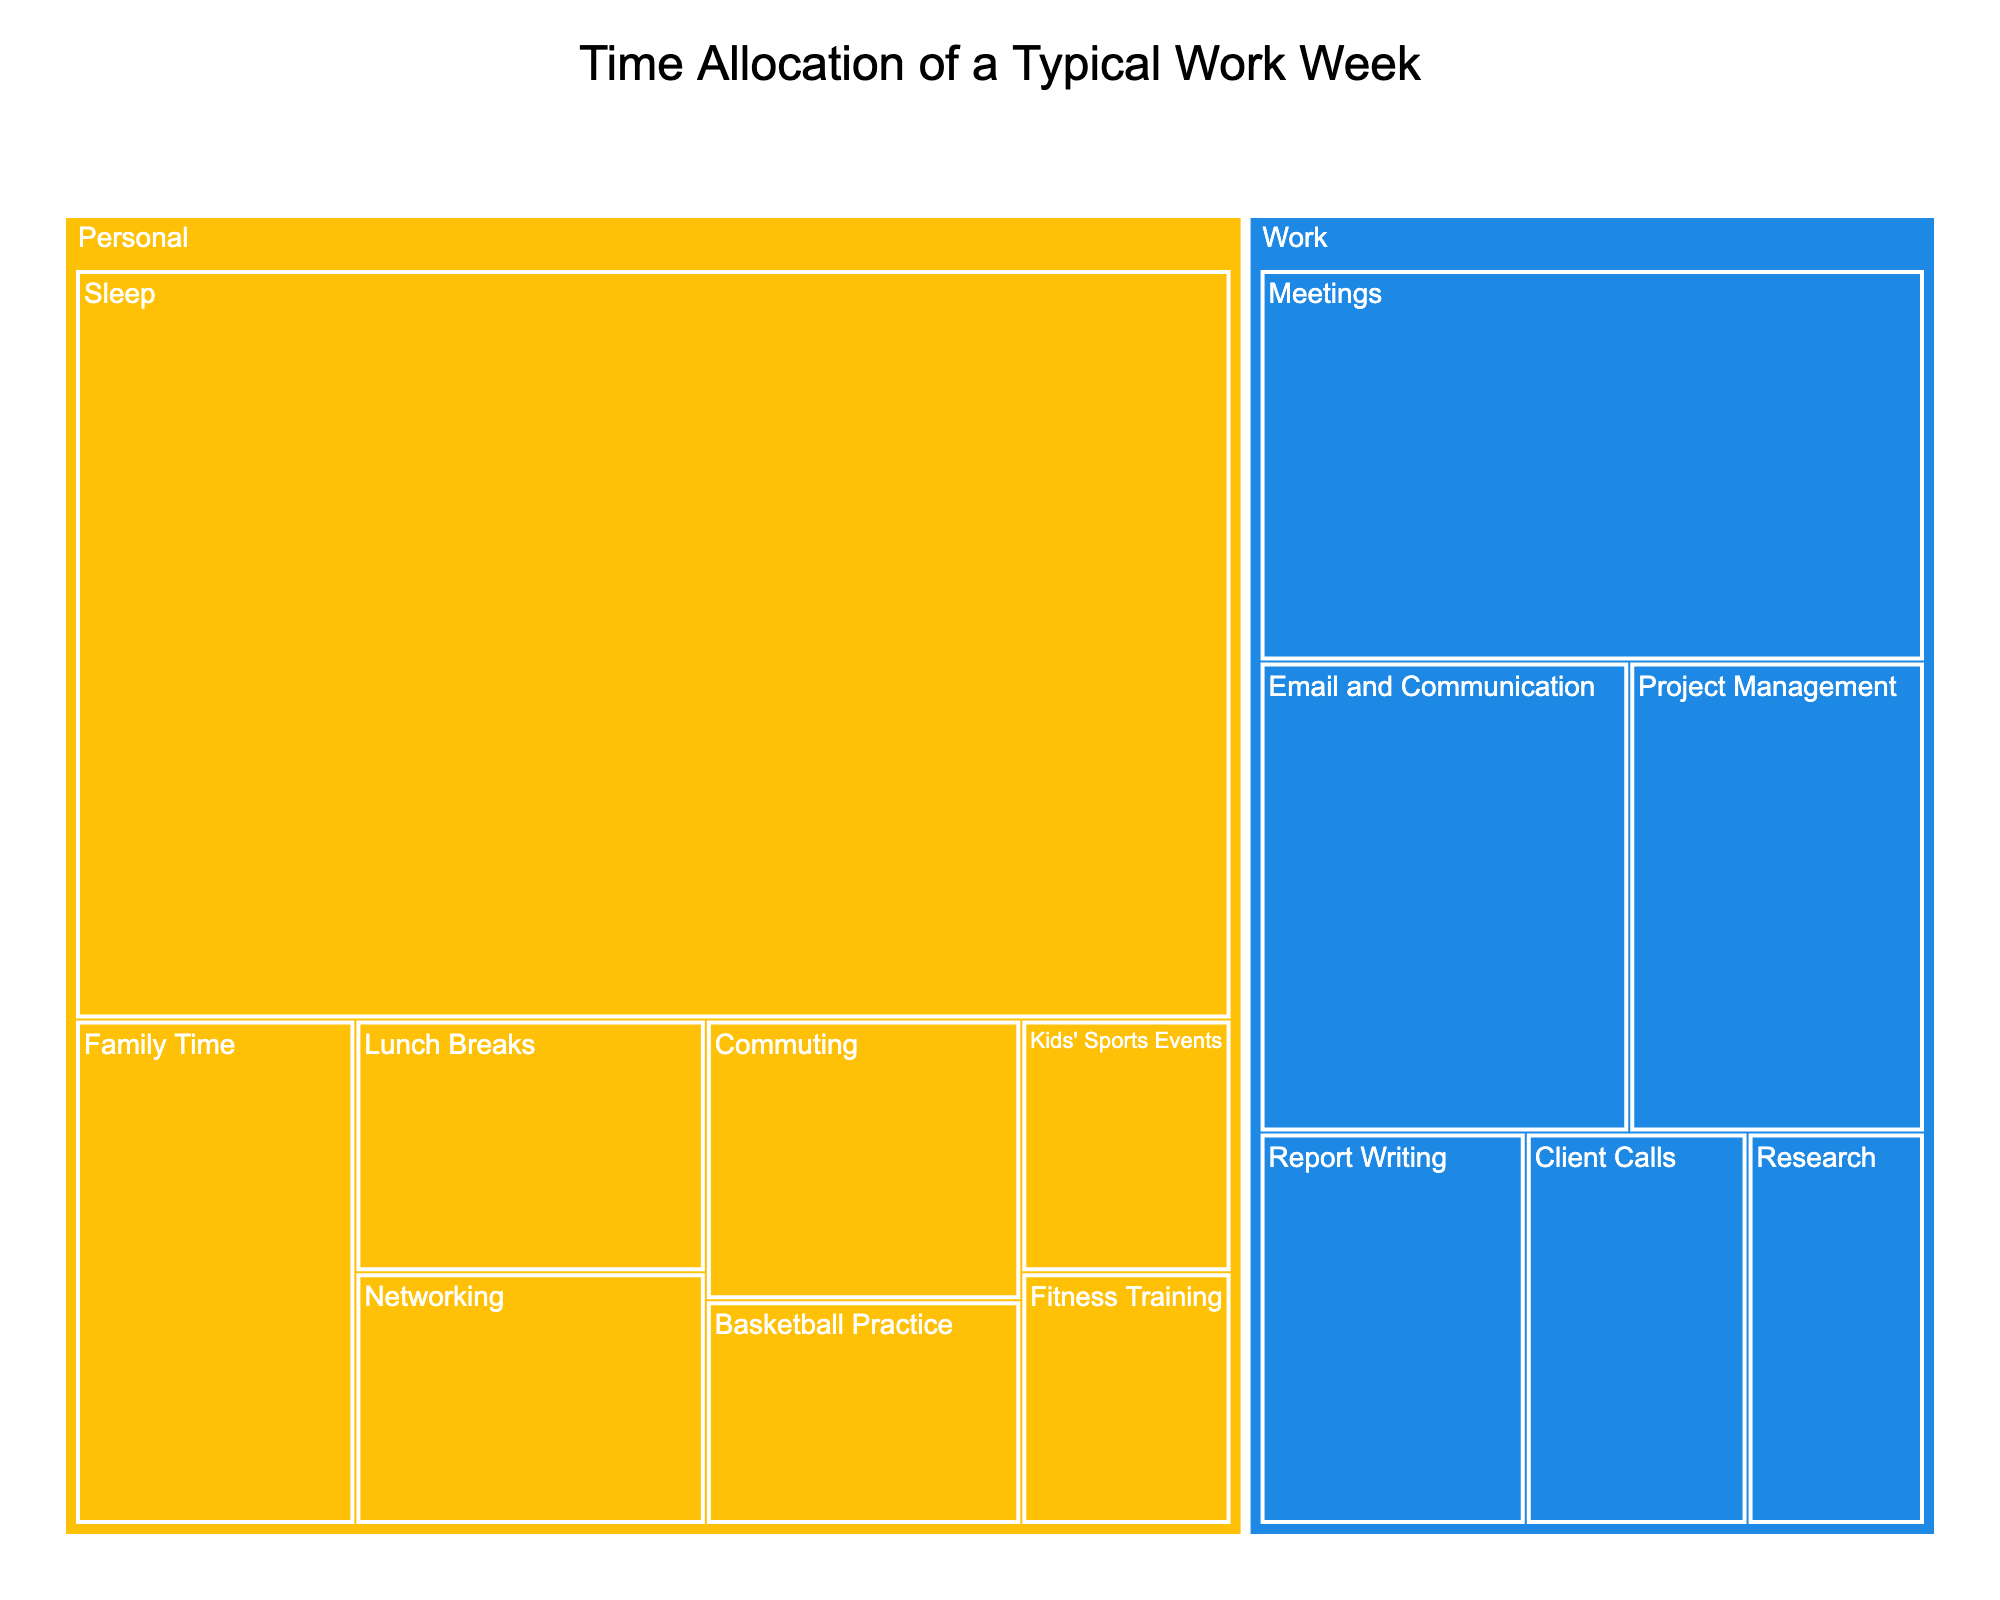What's the title of the figure? The title is usually found at the top of the treemap and helps introduce the purpose or content of the visualization. In this case, by looking at the top of the figure, we can see the title.
Answer: Time Allocation of a Typical Work Week What are the two main categories shown in the figure? The treemap is divided into two primary colors representing the main categories. One can easily identify the categories by observing these color codes.
Answer: Work and Personal Which subcategory under 'Work' has the most hours allocated? Among the subcategories under 'Work', we identify the one with the largest block which corresponds to the highest allocated hours.
Answer: Meetings How many hours are allocated to 'Client Calls' under 'Work'? By finding the 'Client Calls' block under the 'Work' category and looking at its label or the hover information, we can determine the number of hours.
Answer: 5 hours How much total time is spent on 'Fitness Training' and 'Basketball Practice'? By summing the hours for 'Fitness Training' (3 hours) and 'Basketball Practice' (4 hours), we can find the total time spent on these activities.
Answer: 7 hours Which subcategory under 'Personal' takes up the biggest portion of time, and how many hours are spent on it? Under the 'Personal' category, identify the largest block. The label or hover data provides the exact hours for this subcategory.
Answer: Sleep, 49 hours Compare the total time spent on 'Work' and 'Personal' categories. Which one has more hours? Sum all the hours for subcategories under 'Work' and 'Personal' and compare the two totals.
Answer: Personal has more hours How much time is spent on 'Meetings' compared to 'Networking'? Compare the hours allocated to 'Meetings' and 'Networking,' available from their respective blocks under their categories.
Answer: Meetings have 15 hours, Networking has 5 hours What is the total time spent on 'Personal' activities? Add up the hours for all subcategories listed under the 'Personal' category: Commuting, Lunch Breaks, Basketball Practice, Fitness Training, Family Time, Sleep, Kids' Sports Events, Networking.
Answer: 82 hours If you need to free up 5 hours from work-related tasks, which subcategory would you reduce? Identify the subcategory under 'Work' with at least 5 hours allocated to it to consider for reduction. Possible candidates are 'Meetings' (15 hours), 'Email and Communication' (10 hours), or 'Project Management' (8 hours). Choose one of those.
Answer: Meetings, Email and Communication, or Project Management 